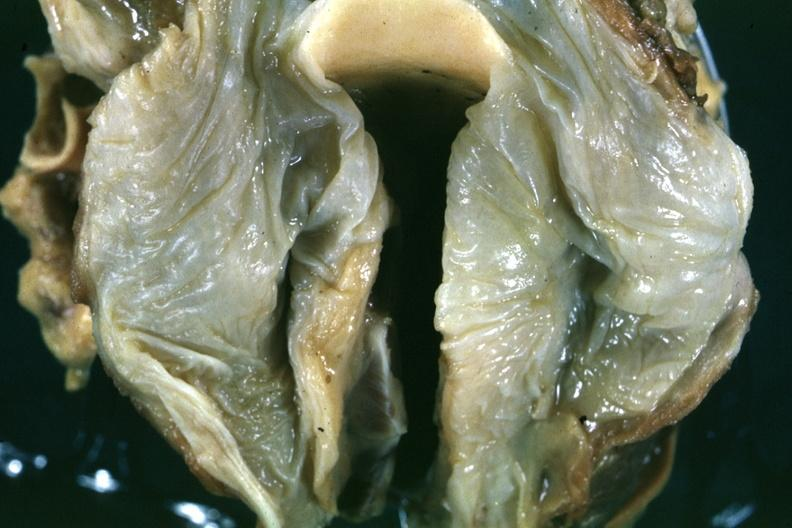what is quite good example of hypopharyngeal edema larynx opened is a close-up in natural color of the edematous mucosal membrane?
Answer the question using a single word or phrase. Opened slide 